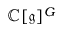Convert formula to latex. <formula><loc_0><loc_0><loc_500><loc_500>\mathbb { C } [ { \mathfrak { g } } ] ^ { G }</formula> 